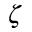<formula> <loc_0><loc_0><loc_500><loc_500>\zeta</formula> 